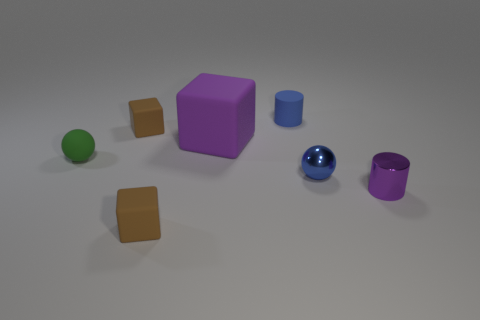What is the shape of the blue rubber object that is the same size as the green ball?
Your response must be concise. Cylinder. Are there any small cylinders of the same color as the big thing?
Keep it short and to the point. Yes. How big is the rubber cylinder?
Your answer should be very brief. Small. Are the purple cylinder and the tiny blue sphere made of the same material?
Ensure brevity in your answer.  Yes. How many matte cubes are to the right of the cube in front of the purple thing that is behind the purple cylinder?
Your answer should be very brief. 1. What shape is the small shiny thing that is behind the small purple object?
Keep it short and to the point. Sphere. What number of other things are there of the same material as the blue cylinder
Your answer should be compact. 4. Do the small metallic ball and the matte cylinder have the same color?
Your response must be concise. Yes. Is the number of metallic objects that are behind the blue matte object less than the number of small objects behind the big cube?
Your answer should be very brief. Yes. There is a matte thing that is the same shape as the tiny blue metal object; what color is it?
Your response must be concise. Green. 